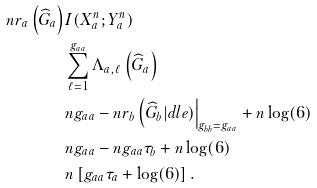Convert formula to latex. <formula><loc_0><loc_0><loc_500><loc_500>n r _ { a } \left ( \widehat { G } _ { a } \right ) & I ( X _ { a } ^ { n } ; Y _ { a } ^ { n } ) \\ & \sum _ { \ell = 1 } ^ { g _ { a a } } \Lambda _ { a , \ell } \left ( \widehat { G } _ { a } \right ) \\ & n g _ { a a } - n r _ { b } \left ( \widehat { G } _ { b } | d l e ) \right | _ { g _ { b b } = g _ { a a } } + n \log ( 6 ) \\ & n g _ { a a } - n g _ { a a } \tau _ { b } + n \log ( 6 ) \\ & n \left [ g _ { a a } \tau _ { a } + \log ( 6 ) \right ] .</formula> 